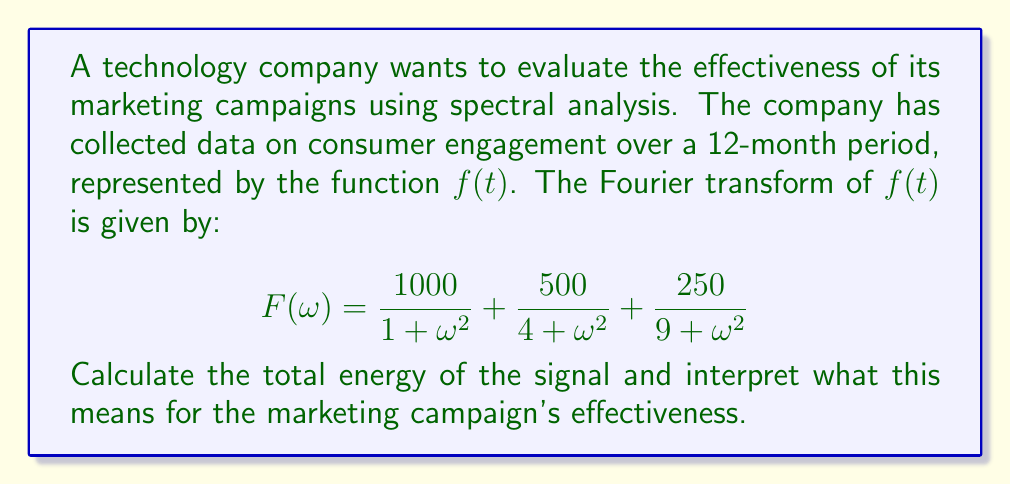Teach me how to tackle this problem. To solve this problem, we'll follow these steps:

1) The total energy of a signal is given by Parseval's theorem:

   $$E = \int_{-\infty}^{\infty} |f(t)|^2 dt = \frac{1}{2\pi} \int_{-\infty}^{\infty} |F(\omega)|^2 d\omega$$

2) In our case, we have:

   $$|F(\omega)|^2 = \left(\frac{1000}{1 + \omega^2} + \frac{500}{4 + \omega^2} + \frac{250}{9 + \omega^2}\right)^2$$

3) Expanding this square would lead to a complicated integral. However, we can simplify by noting that the cross terms will integrate to zero due to the orthogonality of the basis functions. So we can treat each term separately:

   $$E = \frac{1}{2\pi} \int_{-\infty}^{\infty} \left(\frac{1000^2}{(1 + \omega^2)^2} + \frac{500^2}{(4 + \omega^2)^2} + \frac{250^2}{(9 + \omega^2)^2}\right) d\omega$$

4) Each of these integrals has the form:

   $$\int_{-\infty}^{\infty} \frac{A^2}{(a^2 + \omega^2)^2} d\omega = \frac{\pi A^2}{a^3}$$

5) Applying this to our integral:

   $$E = \frac{1}{2\pi} \left(\frac{\pi \cdot 1000^2}{1^3} + \frac{\pi \cdot 500^2}{2^3} + \frac{\pi \cdot 250^2}{3^3}\right)$$

6) Simplifying:

   $$E = 500000 + 31250 + 3472.22 = 534722.22$$

Interpretation: The total energy of the signal represents the overall strength or intensity of the marketing campaign's impact on consumer engagement. A higher energy indicates a more effective campaign, as it suggests stronger and more persistent effects on consumer behavior. The large value we calculated (534,722.22) indicates a significant impact, with the majority of the energy concentrated in the low-frequency component (the first term), suggesting a strong, sustained effect on consumer engagement.
Answer: The total energy of the signal is approximately 534,722.22, indicating a highly effective marketing campaign with a strong, sustained impact on consumer engagement. 